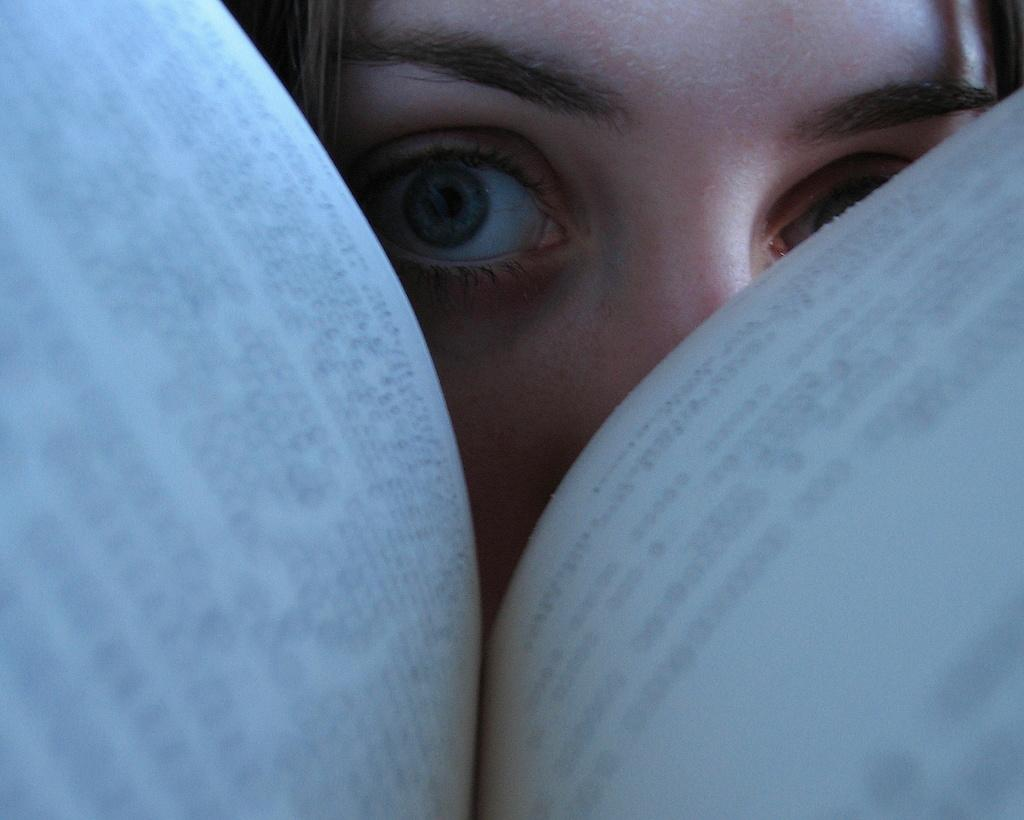What part of a person is visible in the image? There is a woman's eyes visible in the image. What else can be seen in the image besides the woman's eyes? There are two pages visible in the image. What is on the pages that are visible in the image? Something is written on the pages. Where is the pocket located in the image? There is no pocket present in the image. What type of tool is used for raking in the image? There is no rake or any gardening tools present in the image. 